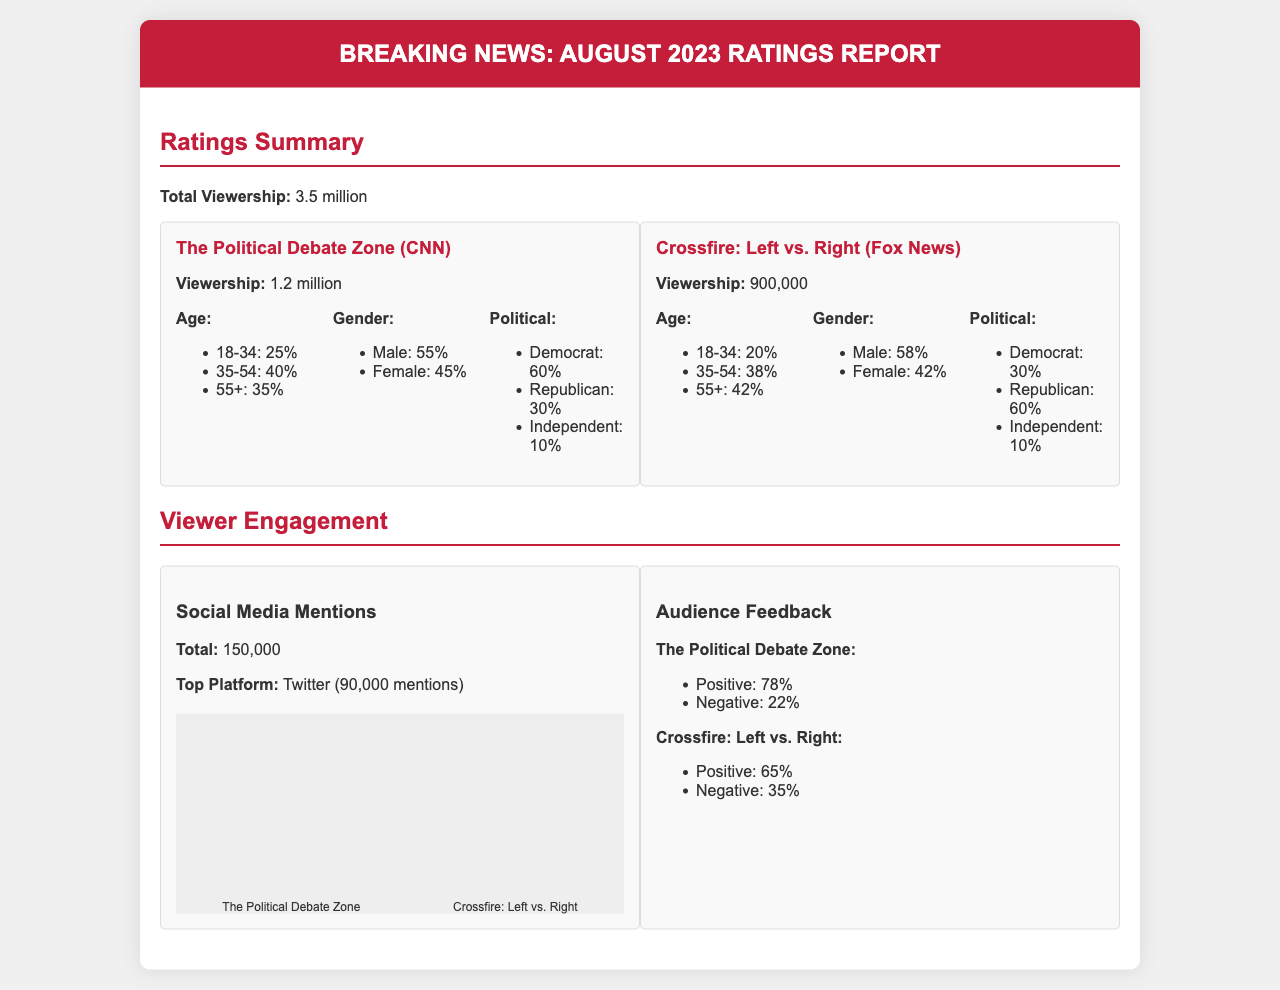What was the total viewership for August 2023? The total viewership is stated as 3.5 million in the document.
Answer: 3.5 million How many viewers did "The Political Debate Zone" attract? The document specifies that "The Political Debate Zone" had a viewership of 1.2 million.
Answer: 1.2 million What percentage of the audience for "Crossfire: Left vs. Right" are Republicans? The viewer demographic for "Crossfire: Left vs. Right" shows that 60% identified as Republican.
Answer: 60% Which show had the higher positive audience feedback percentage? Comparison of audience feedback percentages shows "The Political Debate Zone" with 78% positive feedback and "Crossfire: Left vs. Right" with 65%.
Answer: The Political Debate Zone What is the total number of social media mentions for both shows? The total social media mentions across both shows equal 150,000 (90,000 for Twitter + other platforms).
Answer: 150,000 In what age group does "The Political Debate Zone" have the highest percentage of viewers? The document indicates that 40% of viewers aged 35-54 watch "The Political Debate Zone", making it the highest age group.
Answer: 35-54 What was the top platform for social media mentions? According to the document, Twitter had the highest mentions at 90,000.
Answer: Twitter Which show had a larger share of female viewers? Based on the demographics, "Crossfire: Left vs. Right" has a slightly larger female viewership at 42% compared to 45% for "The Political Debate Zone".
Answer: The Political Debate Zone What is the engagement percentage for negative feedback for "Crossfire: Left vs. Right"? The document denotes that "Crossfire: Left vs. Right" received 35% negative feedback.
Answer: 35% 